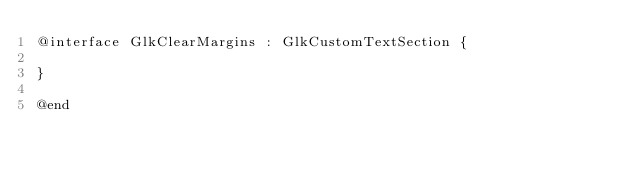<code> <loc_0><loc_0><loc_500><loc_500><_C_>@interface GlkClearMargins : GlkCustomTextSection {

}

@end
</code> 